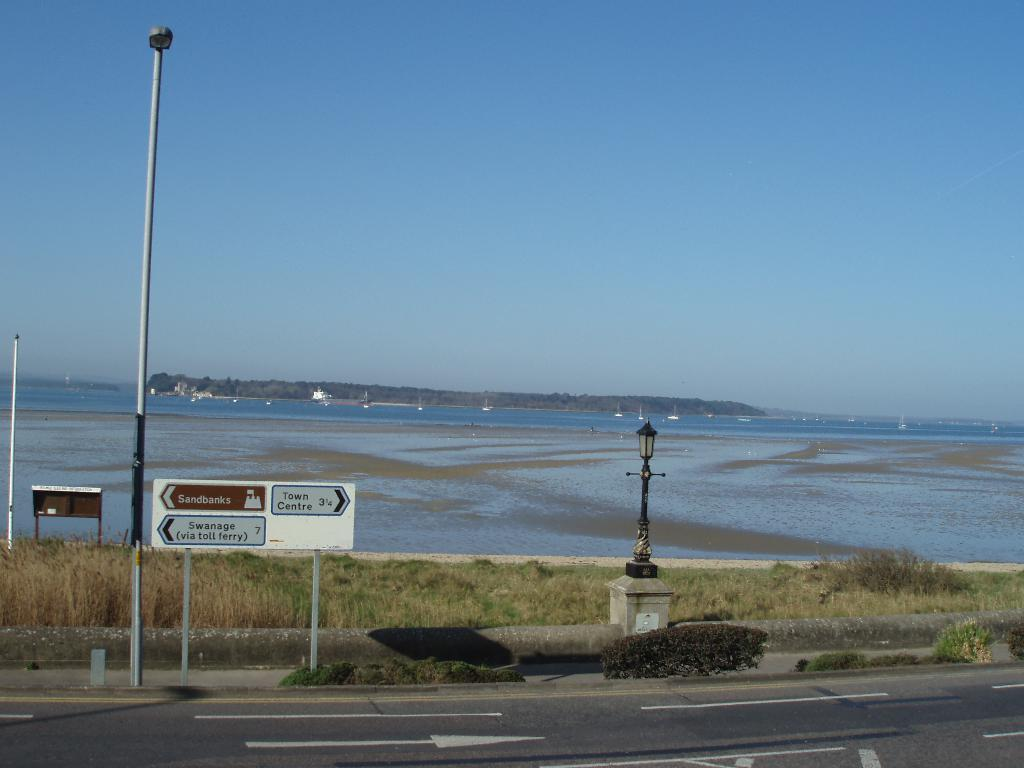What type of vegetation is present in the image? There is grass in the image. What kind of structure can be seen in the image? There is a sign board in the image. What is the purpose of the structure beside the road? There is a light pole on a pillar beside the road, which is likely for illumination purposes. What can be seen in the background of the image? There is water, mountains, and the sky visible in the background of the image. What type of teaching is taking place in the cemetery in the image? There is no cemetery present in the image, and therefore no teaching can be observed. What yard is visible in the image? There is no yard visible in the image; it features grass, a sign board, a light pole, and a street light. 